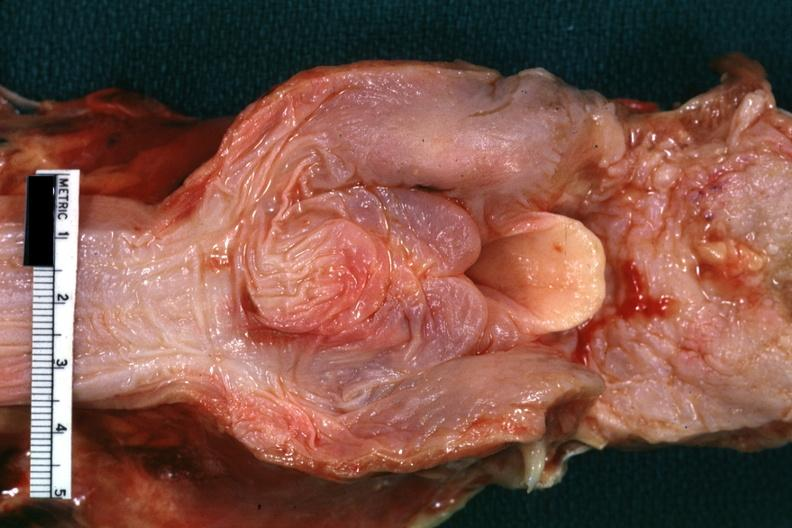what does this image show?
Answer the question using a single word or phrase. View of hypopharyngeal tissue and unopened larynx nice example of severe edema 